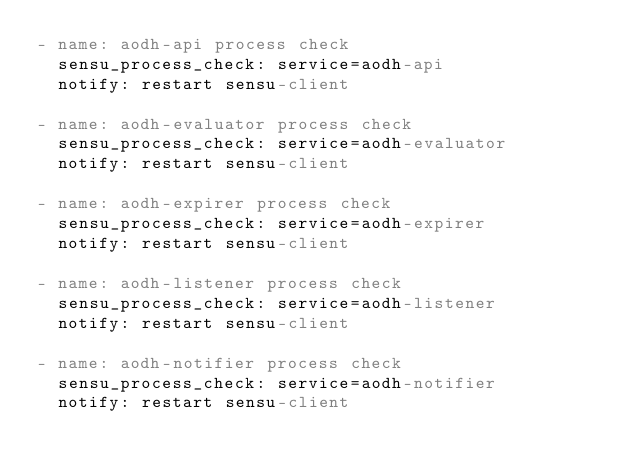Convert code to text. <code><loc_0><loc_0><loc_500><loc_500><_YAML_>- name: aodh-api process check
  sensu_process_check: service=aodh-api
  notify: restart sensu-client

- name: aodh-evaluator process check
  sensu_process_check: service=aodh-evaluator
  notify: restart sensu-client

- name: aodh-expirer process check
  sensu_process_check: service=aodh-expirer
  notify: restart sensu-client

- name: aodh-listener process check
  sensu_process_check: service=aodh-listener
  notify: restart sensu-client
  
- name: aodh-notifier process check
  sensu_process_check: service=aodh-notifier
  notify: restart sensu-client
</code> 